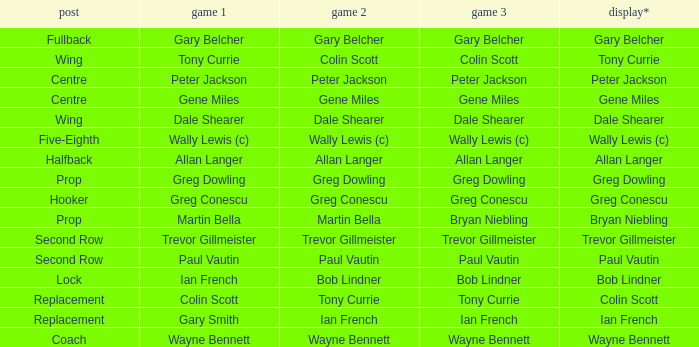What game 1 has halfback as a position? Allan Langer. 